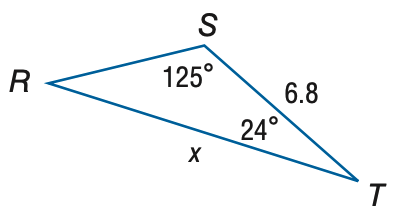Answer the mathemtical geometry problem and directly provide the correct option letter.
Question: Find x. Round to the nearest tenth.
Choices: A: 3.4 B: 4.3 C: 10.8 D: 13.7 C 